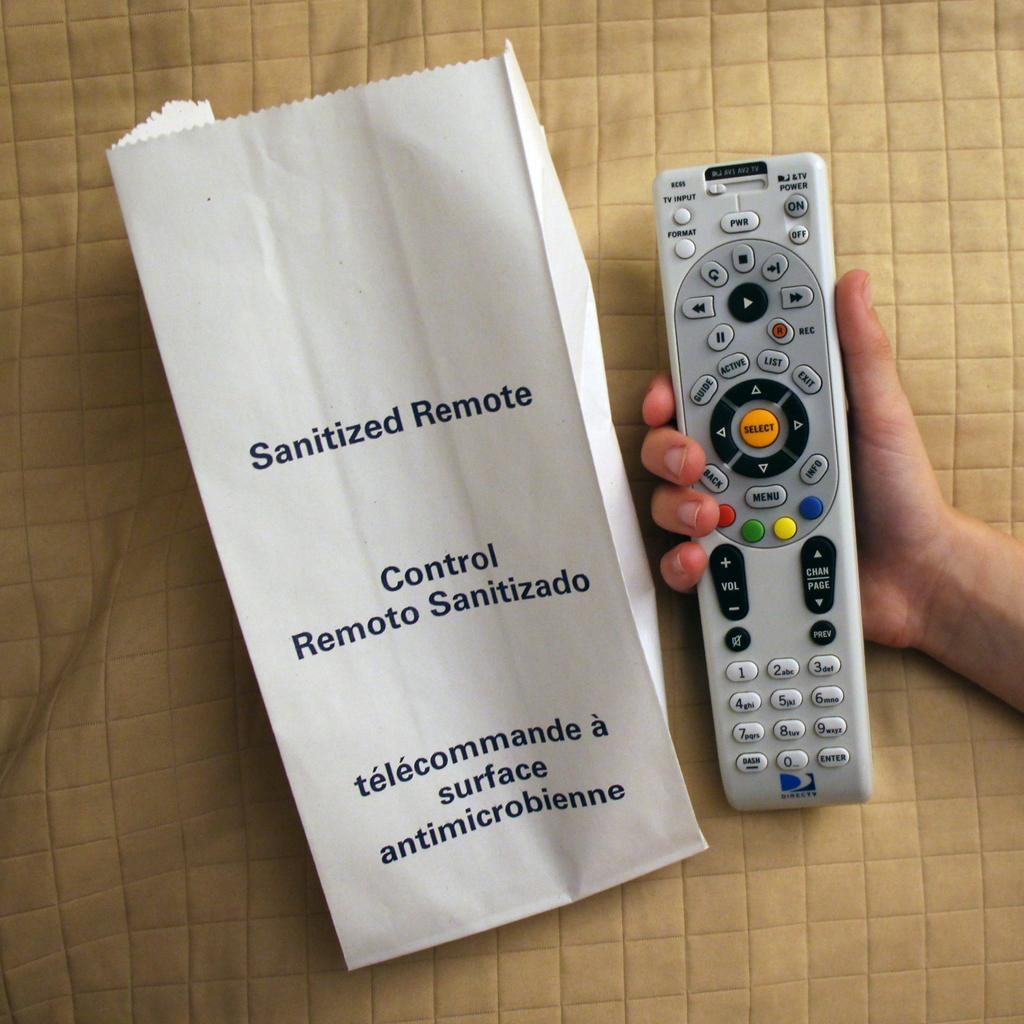<image>
Share a concise interpretation of the image provided. A person holding a remote and a paper bag beside it that says Sanitized Remote 